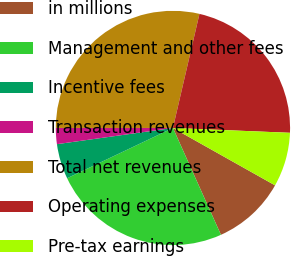<chart> <loc_0><loc_0><loc_500><loc_500><pie_chart><fcel>in millions<fcel>Management and other fees<fcel>Incentive fees<fcel>Transaction revenues<fcel>Total net revenues<fcel>Operating expenses<fcel>Pre-tax earnings<nl><fcel>10.13%<fcel>24.66%<fcel>4.85%<fcel>2.21%<fcel>28.63%<fcel>22.02%<fcel>7.49%<nl></chart> 